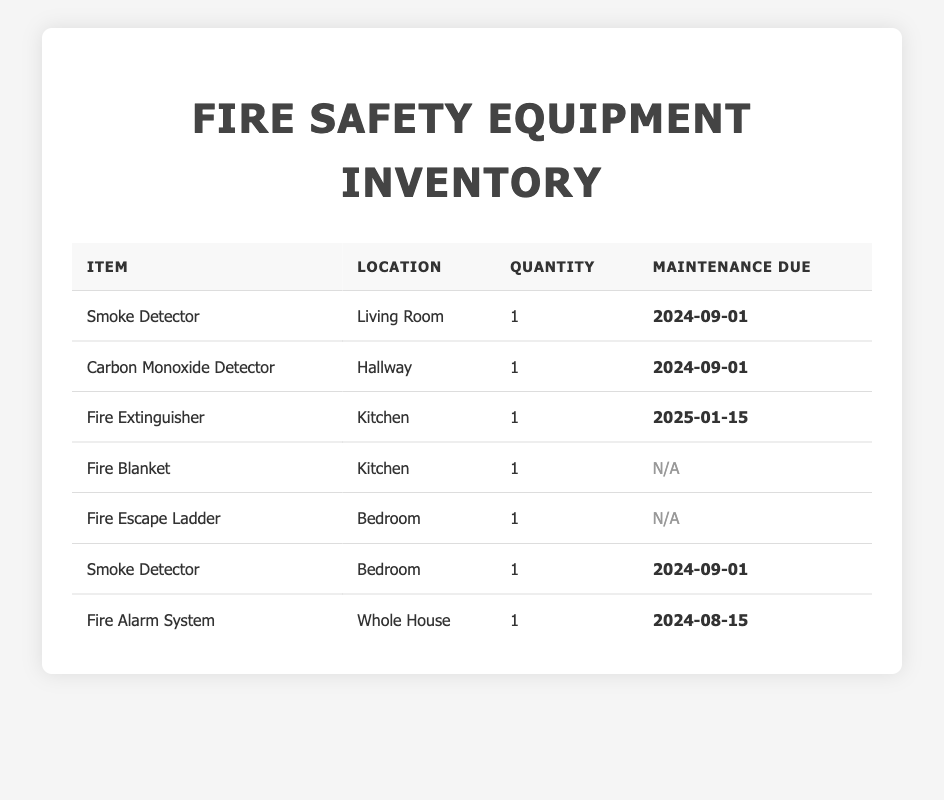What is the maintenance due date for the Fire Extinguisher? The table shows that the maintenance due date for the Fire Extinguisher located in the Kitchen is set for January 15, 2025.
Answer: January 15, 2025 How many smoke detectors are listed in the inventory? The table has two entries for smoke detectors: one in the Living Room and another in the Bedroom, making the total number two.
Answer: 2 Is there a fire alarm system in the house? Yes, the table indicates that there is a Fire Alarm System located in the Whole House.
Answer: Yes Which item has the closest maintenance due date? The Fire Alarm System has the due date of August 15, 2024, which is sooner than the other maintenance due dates listed in the table, making it the closest.
Answer: Fire Alarm System What is the total number of fire safety equipment items? By counting each item listed in the table (Smoke Detector, Carbon Monoxide Detector, Fire Extinguisher, Fire Blanket, Fire Escape Ladder, Smoke Detector, Fire Alarm System), there are a total of 7 items.
Answer: 7 Are there any maintenance due items that are listed as N/A? Yes, both the Fire Blanket and the Fire Escape Ladder have their maintenance noted as N/A in the table.
Answer: Yes What is the difference in maintenance due dates between the earliest and latest items? The earliest maintenance due date is August 15, 2024 (Fire Alarm System) and the latest is January 15, 2025 (Fire Extinguisher). The difference between these dates is about 5 months.
Answer: 5 months Which locations have smoke detectors? The table shows that smoke detectors are located in the Living Room and Bedroom.
Answer: Living Room and Bedroom How often should the smoke detectors be maintained based on the table? The maintenance for the two smoke detectors is due on September 1, 2024, which indicates they should be maintained annually or as required before this date.
Answer: Annually Is there any fire safety equipment in the Kitchen? Yes, the table lists both a Fire Extinguisher and a Fire Blanket located in the Kitchen.
Answer: Yes 